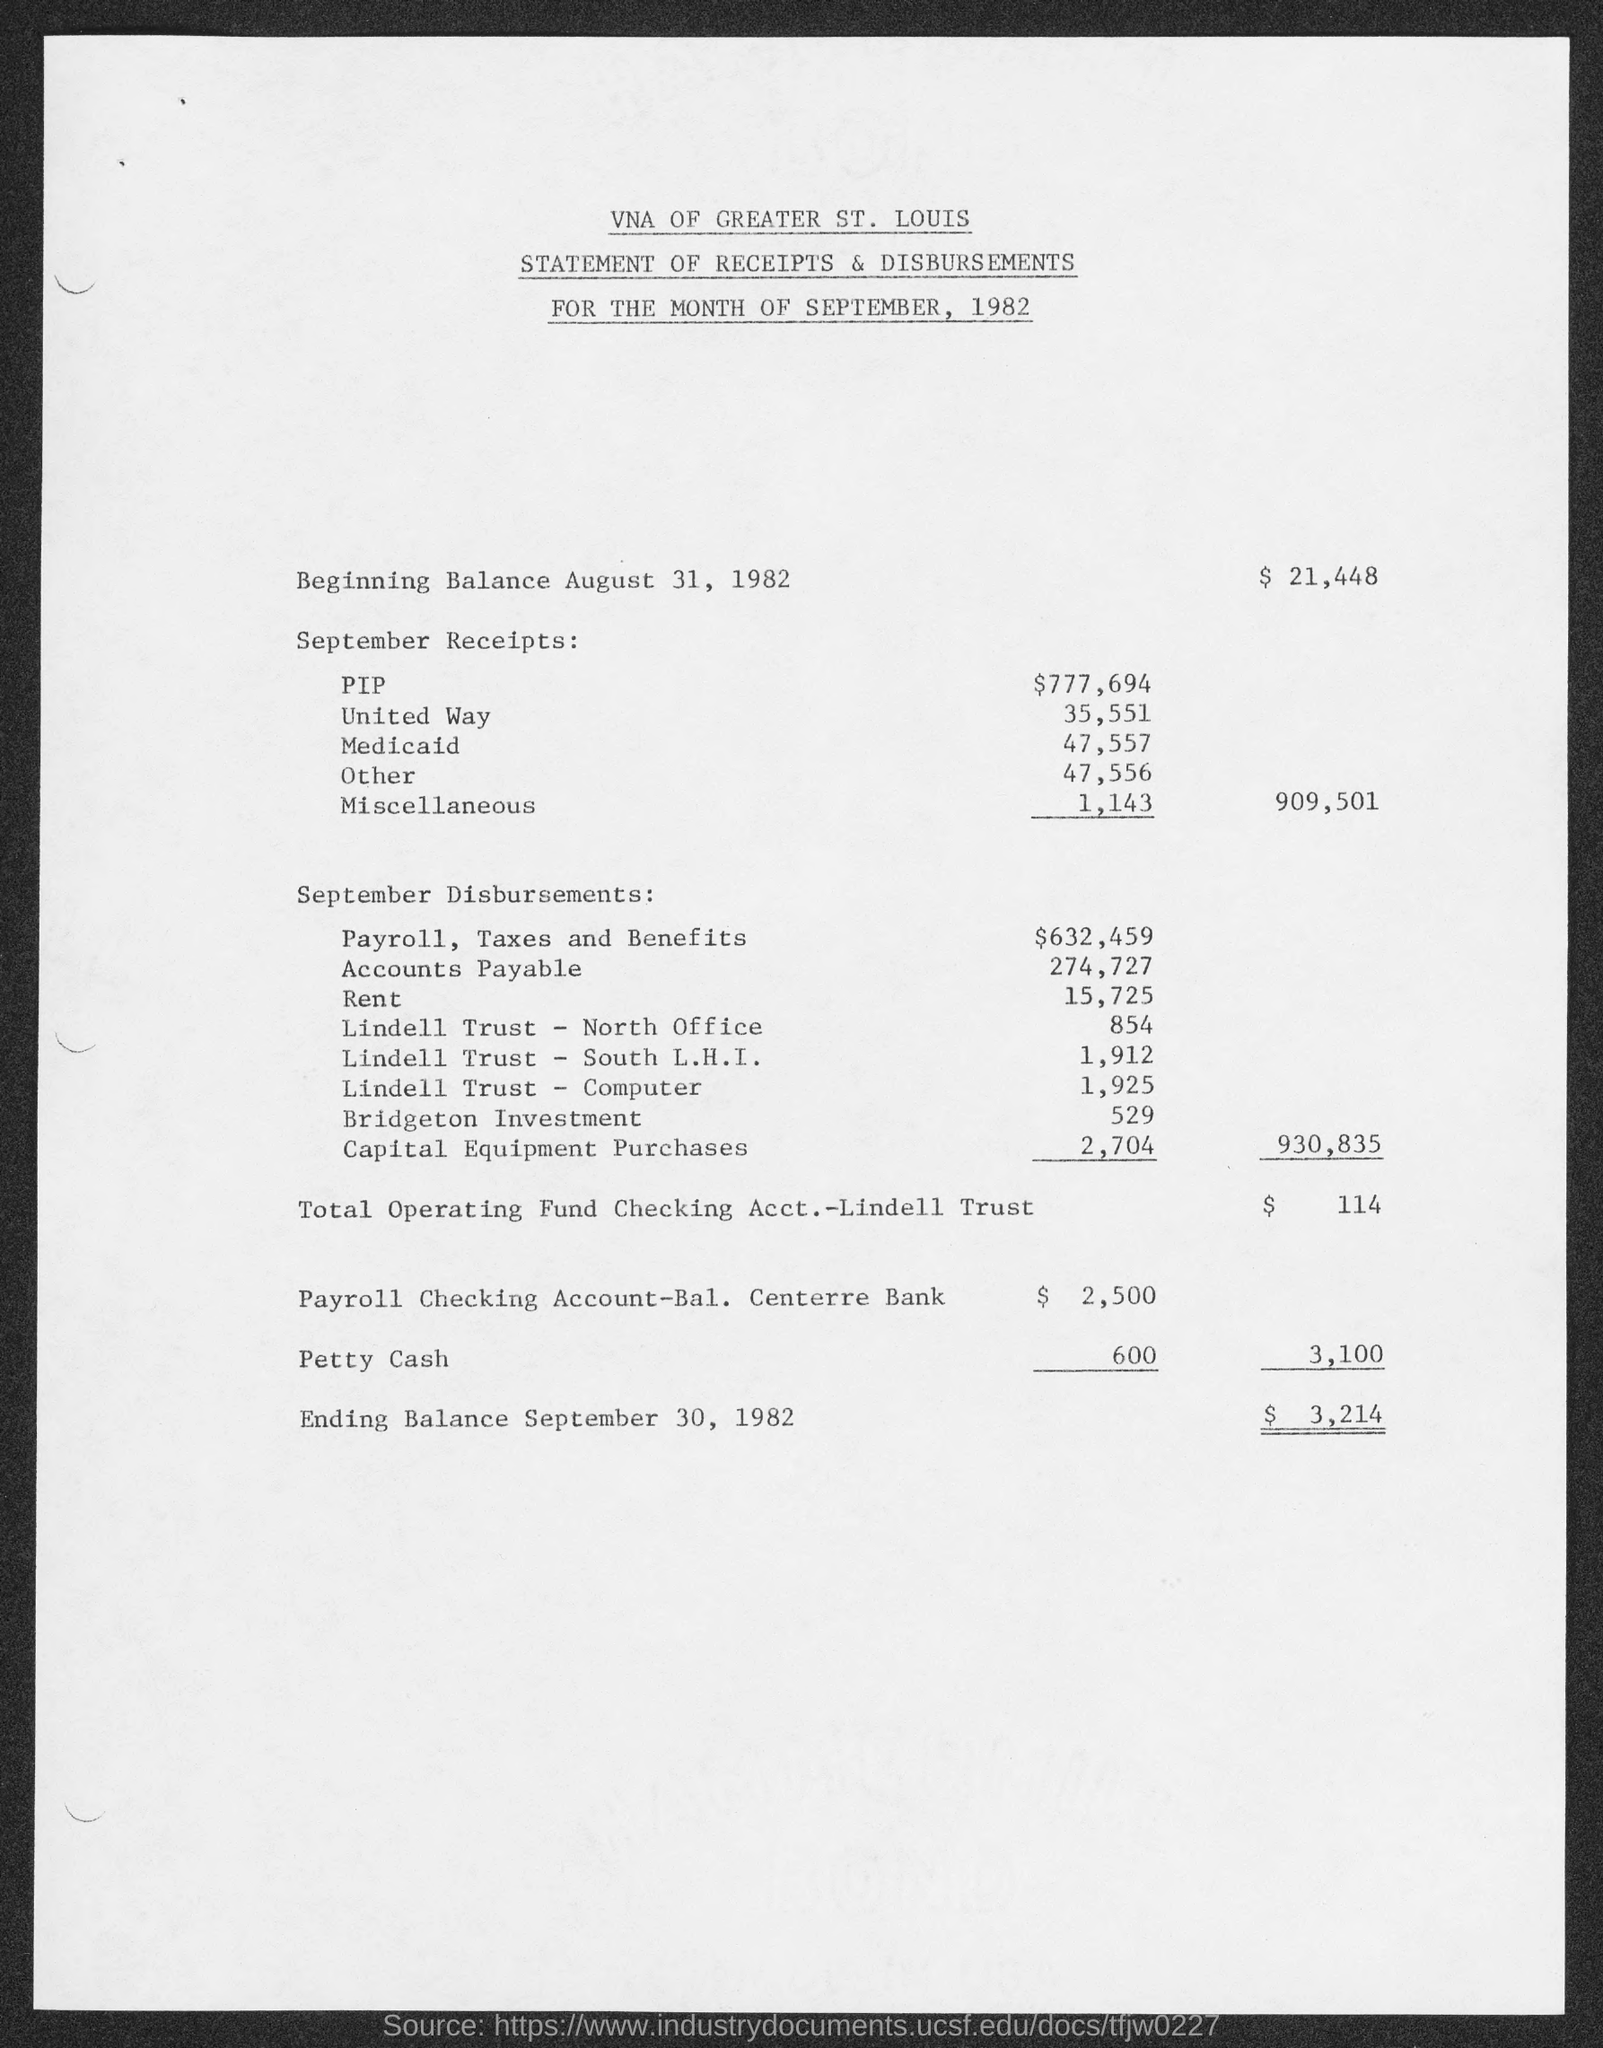Point out several critical features in this image. The third title in the document is 'For the month of September, 1982...' The document begins with the title 'VNA of Greater St. Louis..'. The miscellaneous amount is 1,143. The second title in the document is 'Statement of Receipts & Disbursements.' The rent is 15,725. 